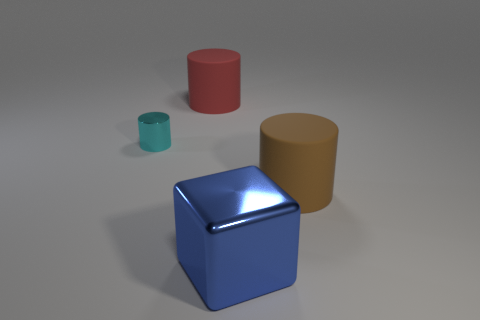How many large rubber objects are the same shape as the small shiny object?
Make the answer very short. 2. How many objects are big rubber cylinders that are behind the metallic cylinder or cylinders right of the big blue thing?
Your response must be concise. 2. There is a big object that is behind the metal thing behind the matte object that is in front of the cyan cylinder; what is it made of?
Ensure brevity in your answer.  Rubber. There is a large object behind the large brown matte object; does it have the same color as the big shiny thing?
Ensure brevity in your answer.  No. What is the material of the thing that is both in front of the tiny cyan cylinder and behind the blue metal thing?
Offer a very short reply. Rubber. Is there a cyan thing of the same size as the brown cylinder?
Ensure brevity in your answer.  No. How many brown spheres are there?
Keep it short and to the point. 0. What number of small objects are in front of the small cylinder?
Keep it short and to the point. 0. Is the material of the red object the same as the brown thing?
Your answer should be compact. Yes. What number of big things are both in front of the cyan cylinder and behind the shiny block?
Provide a short and direct response. 1. 